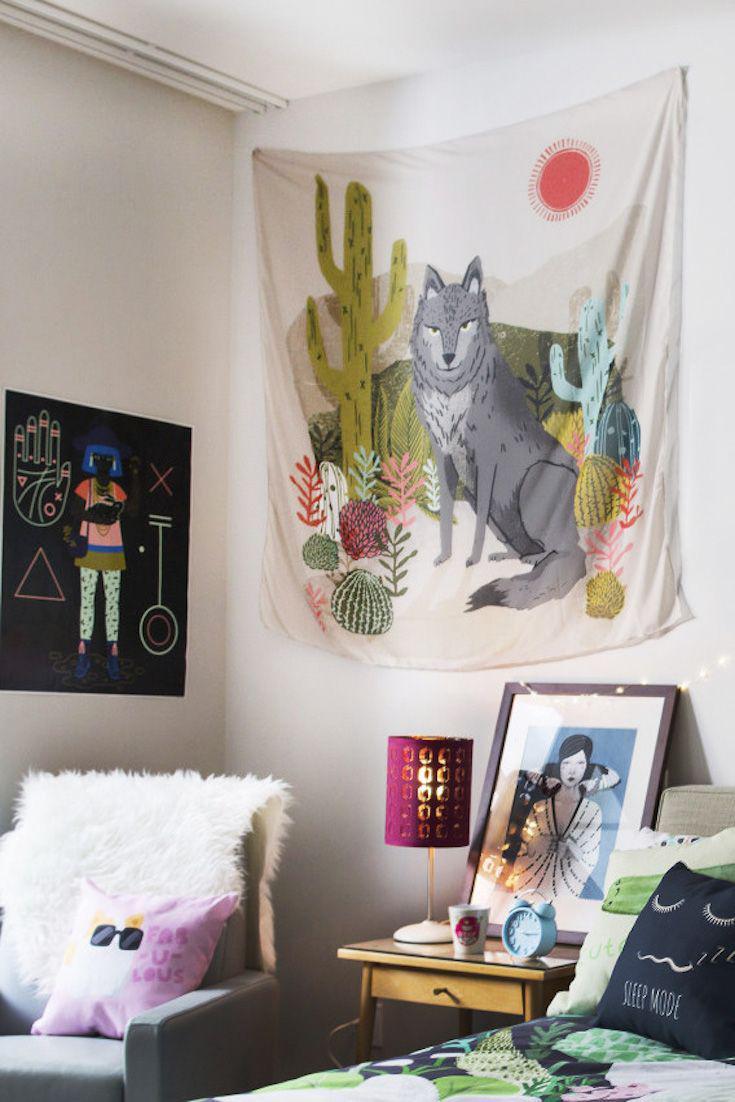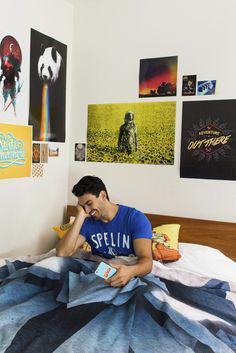The first image is the image on the left, the second image is the image on the right. Given the left and right images, does the statement "An image shows a printed bedspread with no throw pillows on top or people under it." hold true? Answer yes or no. No. 